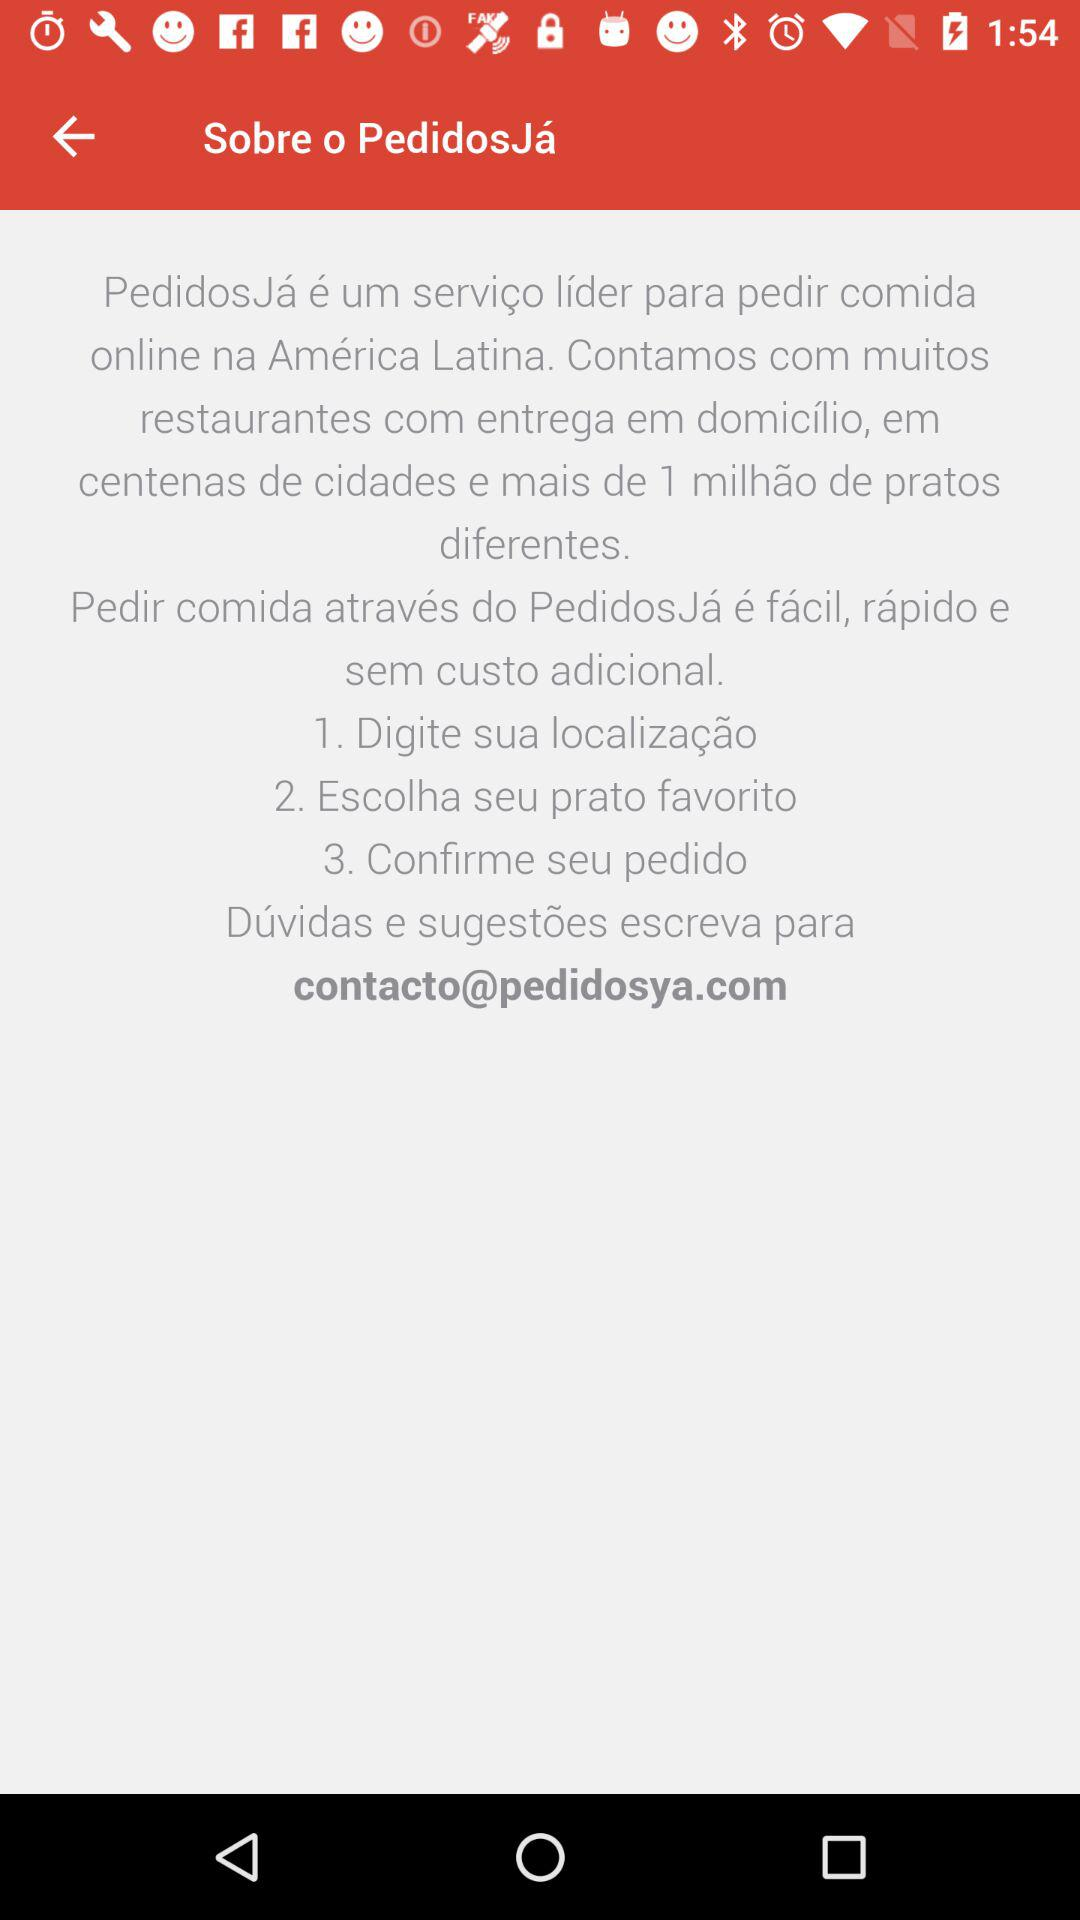How many steps are there in the process of ordering food through PedidosJá?
Answer the question using a single word or phrase. 3 